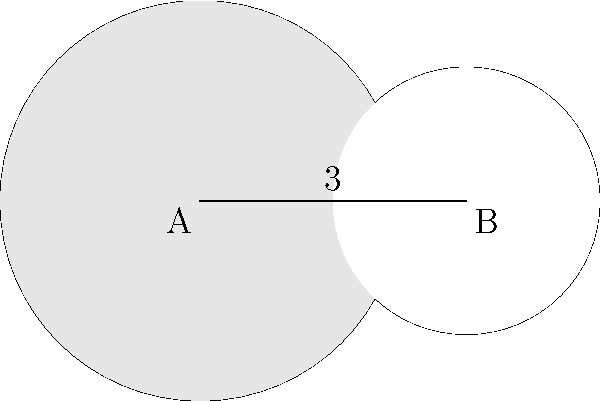Two circles with radii 3 cm and 2 cm have centers that are 4 cm apart, as shown in the figure. Calculate the area of the shaded region between the two circles. Round your answer to two decimal places. To find the area of the shaded region, we need to:

1) Calculate the area of the larger circle
2) Calculate the area of the lens-shaped overlap
3) Subtract the overlap from the larger circle's area

Step 1: Area of larger circle
$$A_1 = \pi r_1^2 = \pi (3^2) = 9\pi \text{ cm}^2$$

Step 2: Area of overlap (lens)
To find this, we need to use the formula for the area of a circular segment:
$$A_{segment} = r^2 \arccos(\frac{d}{2r}) - d\sqrt{r^2-(\frac{d}{2})^2}$$
where $r$ is the radius and $d$ is the length of the chord.

We need to find $d$ using the Pythagorean theorem:
$$d^2 = 4^2 - (3-2)^2 = 15$$
$$d = \sqrt{15}$$

Now we can calculate the area of each segment:

For the larger circle:
$$A_{seg1} = 3^2 \arccos(\frac{\sqrt{15}}{2(3)}) - \sqrt{15}\sqrt{3^2-(\frac{\sqrt{15}}{2})^2}$$

For the smaller circle:
$$A_{seg2} = 2^2 \arccos(\frac{\sqrt{15}}{2(2)}) - \sqrt{15}\sqrt{2^2-(\frac{\sqrt{15}}{2})^2}$$

The total lens area is the sum of these segments:
$$A_{lens} = A_{seg1} + A_{seg2}$$

Step 3: Shaded area
$$A_{shaded} = A_1 - A_{lens}$$

Calculating this numerically and rounding to two decimal places gives the final answer.
Answer: 13.36 cm² 